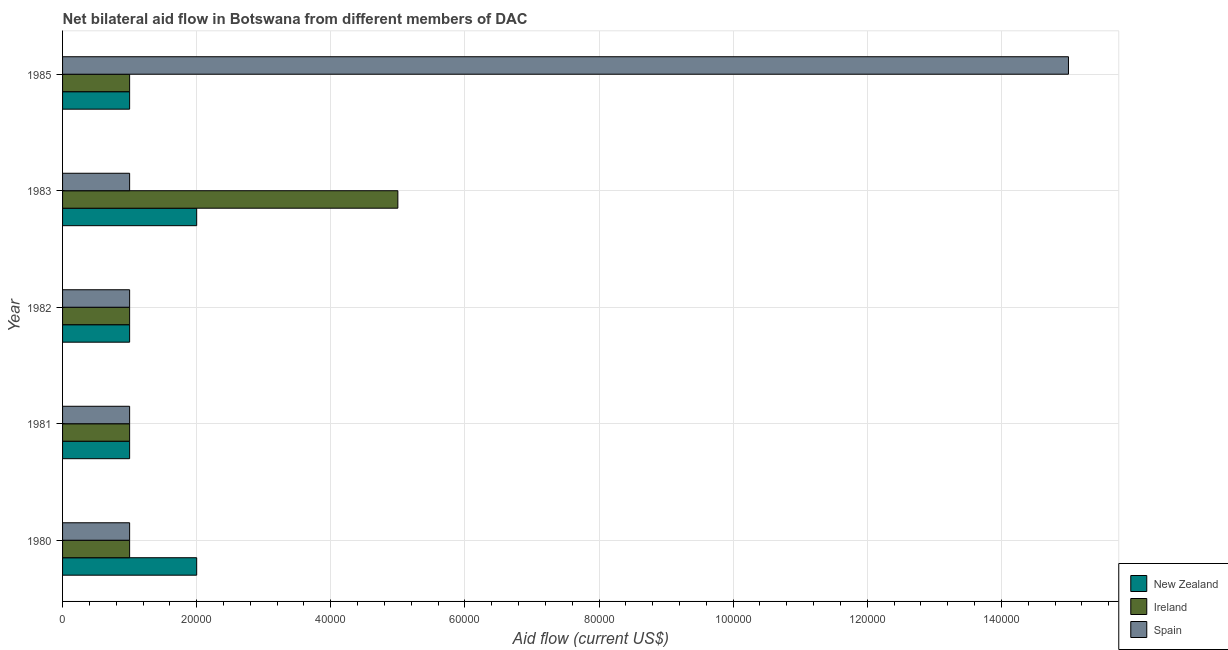How many bars are there on the 3rd tick from the bottom?
Provide a succinct answer. 3. What is the amount of aid provided by ireland in 1981?
Give a very brief answer. 10000. Across all years, what is the maximum amount of aid provided by spain?
Your response must be concise. 1.50e+05. Across all years, what is the minimum amount of aid provided by new zealand?
Provide a succinct answer. 10000. What is the total amount of aid provided by spain in the graph?
Provide a succinct answer. 1.90e+05. What is the difference between the amount of aid provided by new zealand in 1982 and that in 1985?
Provide a short and direct response. 0. What is the difference between the amount of aid provided by ireland in 1983 and the amount of aid provided by new zealand in 1982?
Provide a short and direct response. 4.00e+04. What is the average amount of aid provided by ireland per year?
Give a very brief answer. 1.80e+04. In how many years, is the amount of aid provided by spain greater than 96000 US$?
Offer a very short reply. 1. Is the difference between the amount of aid provided by spain in 1980 and 1981 greater than the difference between the amount of aid provided by new zealand in 1980 and 1981?
Your answer should be very brief. No. What is the difference between the highest and the lowest amount of aid provided by ireland?
Offer a very short reply. 4.00e+04. In how many years, is the amount of aid provided by ireland greater than the average amount of aid provided by ireland taken over all years?
Offer a terse response. 1. Is the sum of the amount of aid provided by new zealand in 1981 and 1985 greater than the maximum amount of aid provided by spain across all years?
Ensure brevity in your answer.  No. What does the 2nd bar from the bottom in 1980 represents?
Offer a very short reply. Ireland. Is it the case that in every year, the sum of the amount of aid provided by new zealand and amount of aid provided by ireland is greater than the amount of aid provided by spain?
Give a very brief answer. No. Are all the bars in the graph horizontal?
Your answer should be very brief. Yes. What is the difference between two consecutive major ticks on the X-axis?
Ensure brevity in your answer.  2.00e+04. Does the graph contain grids?
Offer a very short reply. Yes. How many legend labels are there?
Provide a short and direct response. 3. What is the title of the graph?
Ensure brevity in your answer.  Net bilateral aid flow in Botswana from different members of DAC. Does "Infant(female)" appear as one of the legend labels in the graph?
Your answer should be compact. No. What is the label or title of the X-axis?
Your answer should be compact. Aid flow (current US$). What is the Aid flow (current US$) in Spain in 1980?
Provide a succinct answer. 10000. What is the Aid flow (current US$) in Spain in 1981?
Provide a short and direct response. 10000. What is the Aid flow (current US$) in Ireland in 1982?
Provide a succinct answer. 10000. What is the Aid flow (current US$) of Spain in 1982?
Give a very brief answer. 10000. What is the Aid flow (current US$) of New Zealand in 1983?
Offer a very short reply. 2.00e+04. What is the Aid flow (current US$) in Ireland in 1983?
Keep it short and to the point. 5.00e+04. What is the Aid flow (current US$) in Spain in 1983?
Provide a succinct answer. 10000. What is the Aid flow (current US$) of New Zealand in 1985?
Your answer should be very brief. 10000. What is the Aid flow (current US$) in Ireland in 1985?
Your answer should be compact. 10000. What is the Aid flow (current US$) of Spain in 1985?
Your response must be concise. 1.50e+05. Across all years, what is the maximum Aid flow (current US$) in New Zealand?
Offer a very short reply. 2.00e+04. Across all years, what is the maximum Aid flow (current US$) in Ireland?
Provide a succinct answer. 5.00e+04. Across all years, what is the maximum Aid flow (current US$) of Spain?
Give a very brief answer. 1.50e+05. Across all years, what is the minimum Aid flow (current US$) of New Zealand?
Offer a terse response. 10000. Across all years, what is the minimum Aid flow (current US$) of Ireland?
Make the answer very short. 10000. What is the total Aid flow (current US$) of New Zealand in the graph?
Your answer should be very brief. 7.00e+04. What is the total Aid flow (current US$) in Spain in the graph?
Ensure brevity in your answer.  1.90e+05. What is the difference between the Aid flow (current US$) of New Zealand in 1980 and that in 1981?
Your answer should be compact. 10000. What is the difference between the Aid flow (current US$) in Ireland in 1980 and that in 1981?
Keep it short and to the point. 0. What is the difference between the Aid flow (current US$) in Spain in 1980 and that in 1981?
Your answer should be compact. 0. What is the difference between the Aid flow (current US$) in Spain in 1980 and that in 1982?
Your answer should be compact. 0. What is the difference between the Aid flow (current US$) in Ireland in 1980 and that in 1983?
Offer a terse response. -4.00e+04. What is the difference between the Aid flow (current US$) of New Zealand in 1980 and that in 1985?
Make the answer very short. 10000. What is the difference between the Aid flow (current US$) of Ireland in 1980 and that in 1985?
Ensure brevity in your answer.  0. What is the difference between the Aid flow (current US$) in Spain in 1980 and that in 1985?
Make the answer very short. -1.40e+05. What is the difference between the Aid flow (current US$) of Spain in 1981 and that in 1982?
Offer a very short reply. 0. What is the difference between the Aid flow (current US$) in New Zealand in 1981 and that in 1983?
Keep it short and to the point. -10000. What is the difference between the Aid flow (current US$) of Ireland in 1981 and that in 1983?
Your answer should be compact. -4.00e+04. What is the difference between the Aid flow (current US$) in New Zealand in 1982 and that in 1983?
Give a very brief answer. -10000. What is the difference between the Aid flow (current US$) in Ireland in 1982 and that in 1983?
Ensure brevity in your answer.  -4.00e+04. What is the difference between the Aid flow (current US$) of Spain in 1982 and that in 1983?
Ensure brevity in your answer.  0. What is the difference between the Aid flow (current US$) in New Zealand in 1982 and that in 1985?
Offer a terse response. 0. What is the difference between the Aid flow (current US$) in Ireland in 1982 and that in 1985?
Ensure brevity in your answer.  0. What is the difference between the Aid flow (current US$) of New Zealand in 1983 and that in 1985?
Make the answer very short. 10000. What is the difference between the Aid flow (current US$) of Ireland in 1983 and that in 1985?
Your answer should be compact. 4.00e+04. What is the difference between the Aid flow (current US$) of Spain in 1983 and that in 1985?
Ensure brevity in your answer.  -1.40e+05. What is the difference between the Aid flow (current US$) of New Zealand in 1980 and the Aid flow (current US$) of Ireland in 1981?
Provide a short and direct response. 10000. What is the difference between the Aid flow (current US$) of New Zealand in 1980 and the Aid flow (current US$) of Ireland in 1982?
Your answer should be very brief. 10000. What is the difference between the Aid flow (current US$) of Ireland in 1980 and the Aid flow (current US$) of Spain in 1982?
Your response must be concise. 0. What is the difference between the Aid flow (current US$) in Ireland in 1980 and the Aid flow (current US$) in Spain in 1983?
Ensure brevity in your answer.  0. What is the difference between the Aid flow (current US$) in Ireland in 1980 and the Aid flow (current US$) in Spain in 1985?
Your answer should be very brief. -1.40e+05. What is the difference between the Aid flow (current US$) of New Zealand in 1981 and the Aid flow (current US$) of Ireland in 1982?
Ensure brevity in your answer.  0. What is the difference between the Aid flow (current US$) of Ireland in 1981 and the Aid flow (current US$) of Spain in 1982?
Your response must be concise. 0. What is the difference between the Aid flow (current US$) of New Zealand in 1981 and the Aid flow (current US$) of Spain in 1983?
Provide a succinct answer. 0. What is the difference between the Aid flow (current US$) in Ireland in 1981 and the Aid flow (current US$) in Spain in 1983?
Offer a terse response. 0. What is the difference between the Aid flow (current US$) in New Zealand in 1981 and the Aid flow (current US$) in Spain in 1985?
Provide a succinct answer. -1.40e+05. What is the difference between the Aid flow (current US$) of Ireland in 1981 and the Aid flow (current US$) of Spain in 1985?
Provide a short and direct response. -1.40e+05. What is the difference between the Aid flow (current US$) of New Zealand in 1983 and the Aid flow (current US$) of Spain in 1985?
Your response must be concise. -1.30e+05. What is the difference between the Aid flow (current US$) in Ireland in 1983 and the Aid flow (current US$) in Spain in 1985?
Offer a terse response. -1.00e+05. What is the average Aid flow (current US$) of New Zealand per year?
Your answer should be compact. 1.40e+04. What is the average Aid flow (current US$) in Ireland per year?
Make the answer very short. 1.80e+04. What is the average Aid flow (current US$) of Spain per year?
Keep it short and to the point. 3.80e+04. In the year 1980, what is the difference between the Aid flow (current US$) of New Zealand and Aid flow (current US$) of Spain?
Your answer should be very brief. 10000. In the year 1980, what is the difference between the Aid flow (current US$) in Ireland and Aid flow (current US$) in Spain?
Keep it short and to the point. 0. In the year 1982, what is the difference between the Aid flow (current US$) of New Zealand and Aid flow (current US$) of Ireland?
Your answer should be very brief. 0. In the year 1983, what is the difference between the Aid flow (current US$) of Ireland and Aid flow (current US$) of Spain?
Make the answer very short. 4.00e+04. In the year 1985, what is the difference between the Aid flow (current US$) of New Zealand and Aid flow (current US$) of Ireland?
Provide a short and direct response. 0. In the year 1985, what is the difference between the Aid flow (current US$) in New Zealand and Aid flow (current US$) in Spain?
Ensure brevity in your answer.  -1.40e+05. What is the ratio of the Aid flow (current US$) of Spain in 1980 to that in 1981?
Your response must be concise. 1. What is the ratio of the Aid flow (current US$) in New Zealand in 1980 to that in 1982?
Your answer should be compact. 2. What is the ratio of the Aid flow (current US$) in Ireland in 1980 to that in 1982?
Provide a succinct answer. 1. What is the ratio of the Aid flow (current US$) in Spain in 1980 to that in 1982?
Make the answer very short. 1. What is the ratio of the Aid flow (current US$) of New Zealand in 1980 to that in 1983?
Provide a short and direct response. 1. What is the ratio of the Aid flow (current US$) in Spain in 1980 to that in 1983?
Your response must be concise. 1. What is the ratio of the Aid flow (current US$) in Ireland in 1980 to that in 1985?
Make the answer very short. 1. What is the ratio of the Aid flow (current US$) in Spain in 1980 to that in 1985?
Provide a succinct answer. 0.07. What is the ratio of the Aid flow (current US$) in New Zealand in 1981 to that in 1982?
Give a very brief answer. 1. What is the ratio of the Aid flow (current US$) of Spain in 1981 to that in 1982?
Make the answer very short. 1. What is the ratio of the Aid flow (current US$) in New Zealand in 1981 to that in 1983?
Give a very brief answer. 0.5. What is the ratio of the Aid flow (current US$) of Spain in 1981 to that in 1983?
Offer a very short reply. 1. What is the ratio of the Aid flow (current US$) in New Zealand in 1981 to that in 1985?
Your answer should be compact. 1. What is the ratio of the Aid flow (current US$) of Spain in 1981 to that in 1985?
Provide a short and direct response. 0.07. What is the ratio of the Aid flow (current US$) of New Zealand in 1982 to that in 1983?
Provide a short and direct response. 0.5. What is the ratio of the Aid flow (current US$) of Ireland in 1982 to that in 1983?
Keep it short and to the point. 0.2. What is the ratio of the Aid flow (current US$) in Spain in 1982 to that in 1985?
Offer a terse response. 0.07. What is the ratio of the Aid flow (current US$) of Ireland in 1983 to that in 1985?
Offer a very short reply. 5. What is the ratio of the Aid flow (current US$) of Spain in 1983 to that in 1985?
Make the answer very short. 0.07. What is the difference between the highest and the second highest Aid flow (current US$) of Ireland?
Provide a short and direct response. 4.00e+04. What is the difference between the highest and the lowest Aid flow (current US$) in New Zealand?
Ensure brevity in your answer.  10000. What is the difference between the highest and the lowest Aid flow (current US$) in Ireland?
Keep it short and to the point. 4.00e+04. What is the difference between the highest and the lowest Aid flow (current US$) in Spain?
Your answer should be compact. 1.40e+05. 